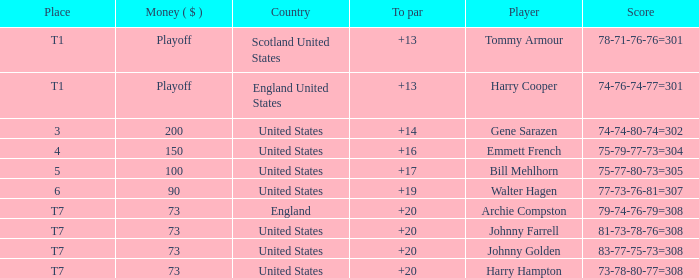What is the score for the United States when Harry Hampton is the player and the money is $73? 73-78-80-77=308. 